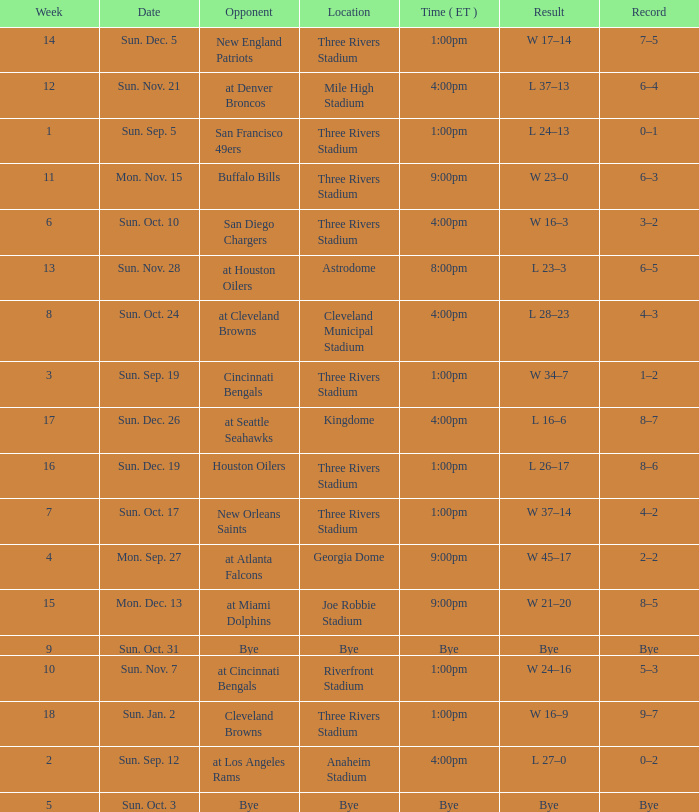What is the result of the game at three rivers stadium with a Record of 6–3? W 23–0. 